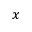<formula> <loc_0><loc_0><loc_500><loc_500>x</formula> 